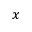<formula> <loc_0><loc_0><loc_500><loc_500>x</formula> 